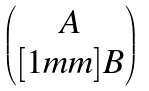<formula> <loc_0><loc_0><loc_500><loc_500>\begin{pmatrix} A \\ [ 1 m m ] B \end{pmatrix}</formula> 